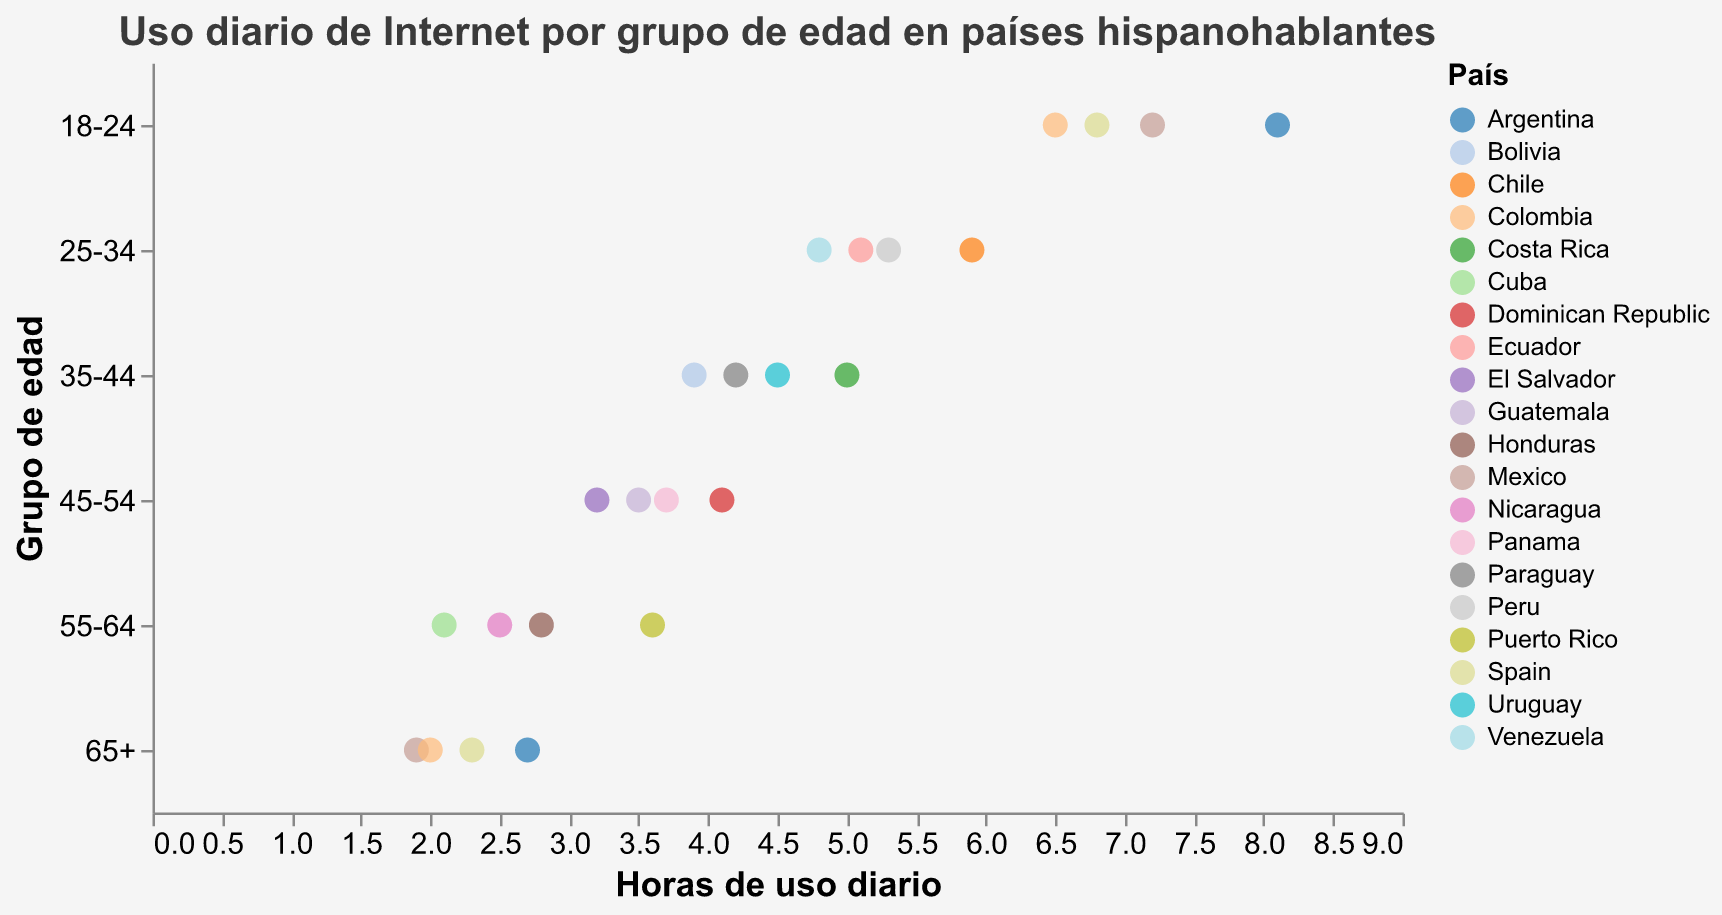¿Qué grupo de edad tiene el mayor uso diario de internet? Para determinarlo, observamos la posición más alta en el eje de "Grupo de edad" y buscamos el valor más alto en "Horas de uso diario". El grupo "18-24" tiene la duración más alta de 8.1 horas.
Answer: 18-24 ¿Cuántas horas utiliza internet la persona promedio del grupo de edad 25-34 en Venezuela? Encontramos el punto correspondiente al país Venezuela en el grupo de edad "25-34" en el gráfico. El valor de uso diario de internet es 4.8 horas.
Answer: 4.8 ¿Cuál es la diferencia en horas de uso diario de internet entre los grupos de edad 18-24 y 65+ en Argentina? Buscamos y tomamos los valores de uso diario de internet para Argentina en los grupos "18-24" y "65+". Restamos 2.7 de 8.1.
Answer: 5.4 ¿Qué país tiene el menor uso diario de internet en el grupo de edad 55-64? Observamos los puntos en el grupo de edad "55-64" y localizamos el valor más bajo. Identificamos que Cuba tiene el menor uso diario con 2.1 horas.
Answer: Cuba ¿El uso diario de internet de México para el grupo de edad 18-24 es mayor que el uso diario de internet en Colombia para el mismo grupo de edad? Comparamos las horas de uso diario entre México (7.2) y Colombia (6.5) para el grupo de 18-24 años. 7.2 es mayor que 6.5.
Answer: Sí ¿Cuál es el promedio de horas de uso diario de internet para los países en el grupo de edad 35-44? Sumamos los valores de las horas diarias de uso de internet para todos los países en el grupo 35-44 y dividimos por el número de países. La suma es (4.5 + 3.9 + 4.2 + 5.0) = 17.6; y el promedio es 17.6/4 = 4.4.
Answer: 4.4 ¿Cuál es el grupo de edad con el menor uso diario de internet en general? Observamos las horas de uso diario más bajas para cada grupo de edad y comparamos. El grupo "65+" tiene los valores más bajos (desde 1.9 hasta 2.7).
Answer: 65+ ¿Hay algún grupo de edad en el que todos los países tengan más de 4 horas de uso diario de internet? Recorremos los puntos de cada grupo de edad y verificamos si todos los valores son mayores a 4. El grupo "18-24" cumple con esta condición.
Answer: 18-24 ¿Cuál es la diferencia en el uso diario de internet entre los grupos de edad 45-54 en Panamá y El Salvador? Restamos las horas de uso diario entre Panamá (3.7) y El Salvador (3.2). La diferencia es 3.7 - 3.2 = 0.5.
Answer: 0.5 ¿Qué país tiene el mayor uso diario de internet para el grupo de edad 25-34? Encontramos el valor más alto dentro del grupo de edad 25-34. Chile tiene el mayor uso diario con 5.9 horas.
Answer: Chile 